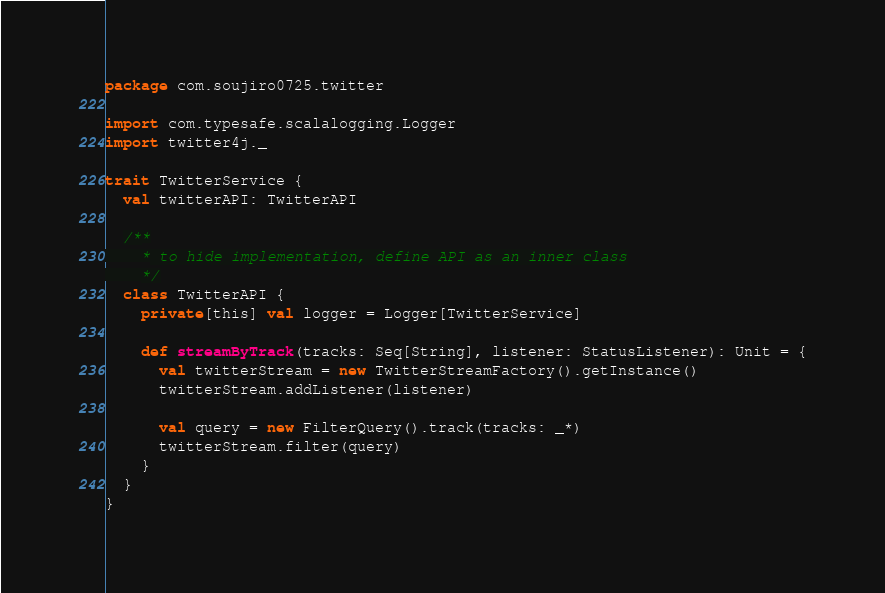<code> <loc_0><loc_0><loc_500><loc_500><_Scala_>package com.soujiro0725.twitter

import com.typesafe.scalalogging.Logger
import twitter4j._

trait TwitterService {
  val twitterAPI: TwitterAPI

  /**
    * to hide implementation, define API as an inner class
    */
  class TwitterAPI {
    private[this] val logger = Logger[TwitterService]

    def streamByTrack(tracks: Seq[String], listener: StatusListener): Unit = {
      val twitterStream = new TwitterStreamFactory().getInstance()
      twitterStream.addListener(listener)

      val query = new FilterQuery().track(tracks: _*)
      twitterStream.filter(query)
    }
  }
}
</code> 